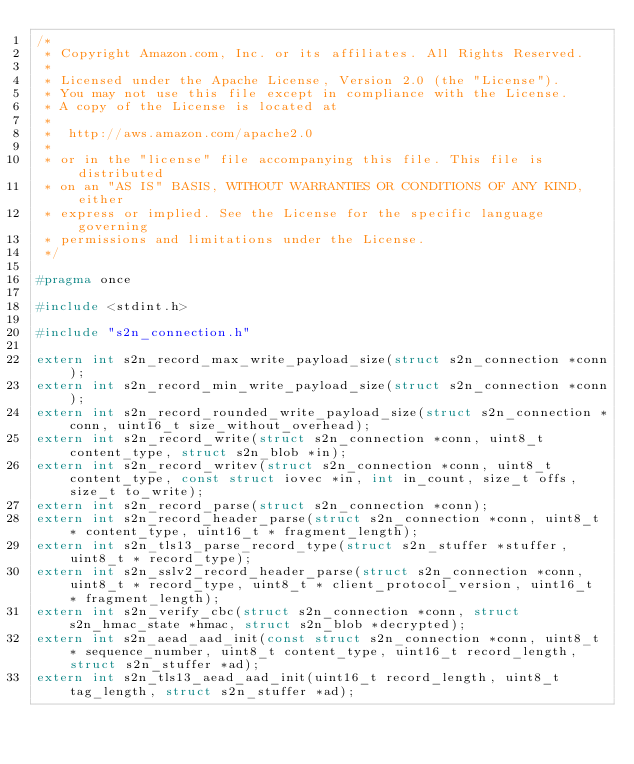<code> <loc_0><loc_0><loc_500><loc_500><_C_>/*
 * Copyright Amazon.com, Inc. or its affiliates. All Rights Reserved.
 *
 * Licensed under the Apache License, Version 2.0 (the "License").
 * You may not use this file except in compliance with the License.
 * A copy of the License is located at
 *
 *  http://aws.amazon.com/apache2.0
 *
 * or in the "license" file accompanying this file. This file is distributed
 * on an "AS IS" BASIS, WITHOUT WARRANTIES OR CONDITIONS OF ANY KIND, either
 * express or implied. See the License for the specific language governing
 * permissions and limitations under the License.
 */

#pragma once

#include <stdint.h>

#include "s2n_connection.h"

extern int s2n_record_max_write_payload_size(struct s2n_connection *conn);
extern int s2n_record_min_write_payload_size(struct s2n_connection *conn);
extern int s2n_record_rounded_write_payload_size(struct s2n_connection *conn, uint16_t size_without_overhead);
extern int s2n_record_write(struct s2n_connection *conn, uint8_t content_type, struct s2n_blob *in);
extern int s2n_record_writev(struct s2n_connection *conn, uint8_t content_type, const struct iovec *in, int in_count, size_t offs, size_t to_write);
extern int s2n_record_parse(struct s2n_connection *conn);
extern int s2n_record_header_parse(struct s2n_connection *conn, uint8_t * content_type, uint16_t * fragment_length);
extern int s2n_tls13_parse_record_type(struct s2n_stuffer *stuffer, uint8_t * record_type);
extern int s2n_sslv2_record_header_parse(struct s2n_connection *conn, uint8_t * record_type, uint8_t * client_protocol_version, uint16_t * fragment_length);
extern int s2n_verify_cbc(struct s2n_connection *conn, struct s2n_hmac_state *hmac, struct s2n_blob *decrypted);
extern int s2n_aead_aad_init(const struct s2n_connection *conn, uint8_t * sequence_number, uint8_t content_type, uint16_t record_length, struct s2n_stuffer *ad);
extern int s2n_tls13_aead_aad_init(uint16_t record_length, uint8_t tag_length, struct s2n_stuffer *ad);
</code> 